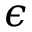<formula> <loc_0><loc_0><loc_500><loc_500>\epsilon</formula> 